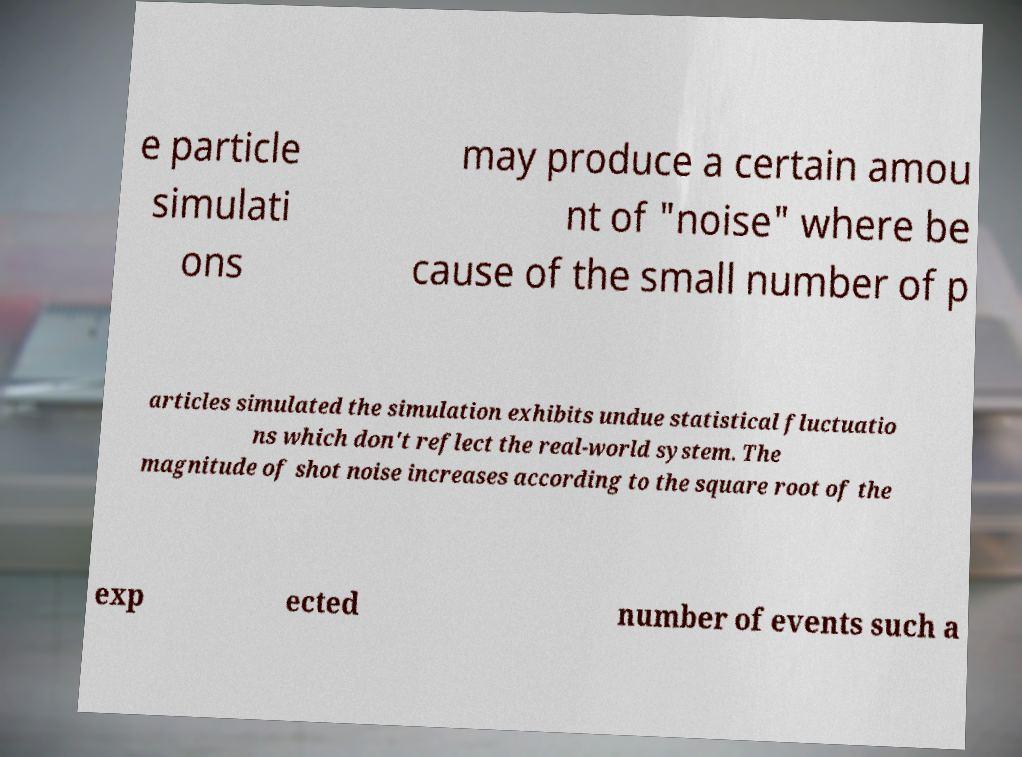I need the written content from this picture converted into text. Can you do that? e particle simulati ons may produce a certain amou nt of "noise" where be cause of the small number of p articles simulated the simulation exhibits undue statistical fluctuatio ns which don't reflect the real-world system. The magnitude of shot noise increases according to the square root of the exp ected number of events such a 